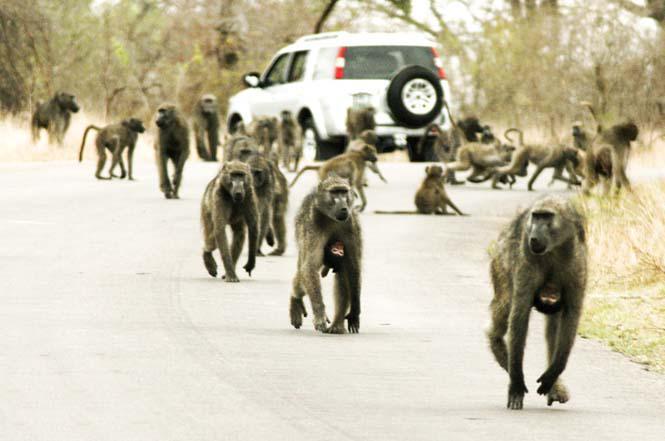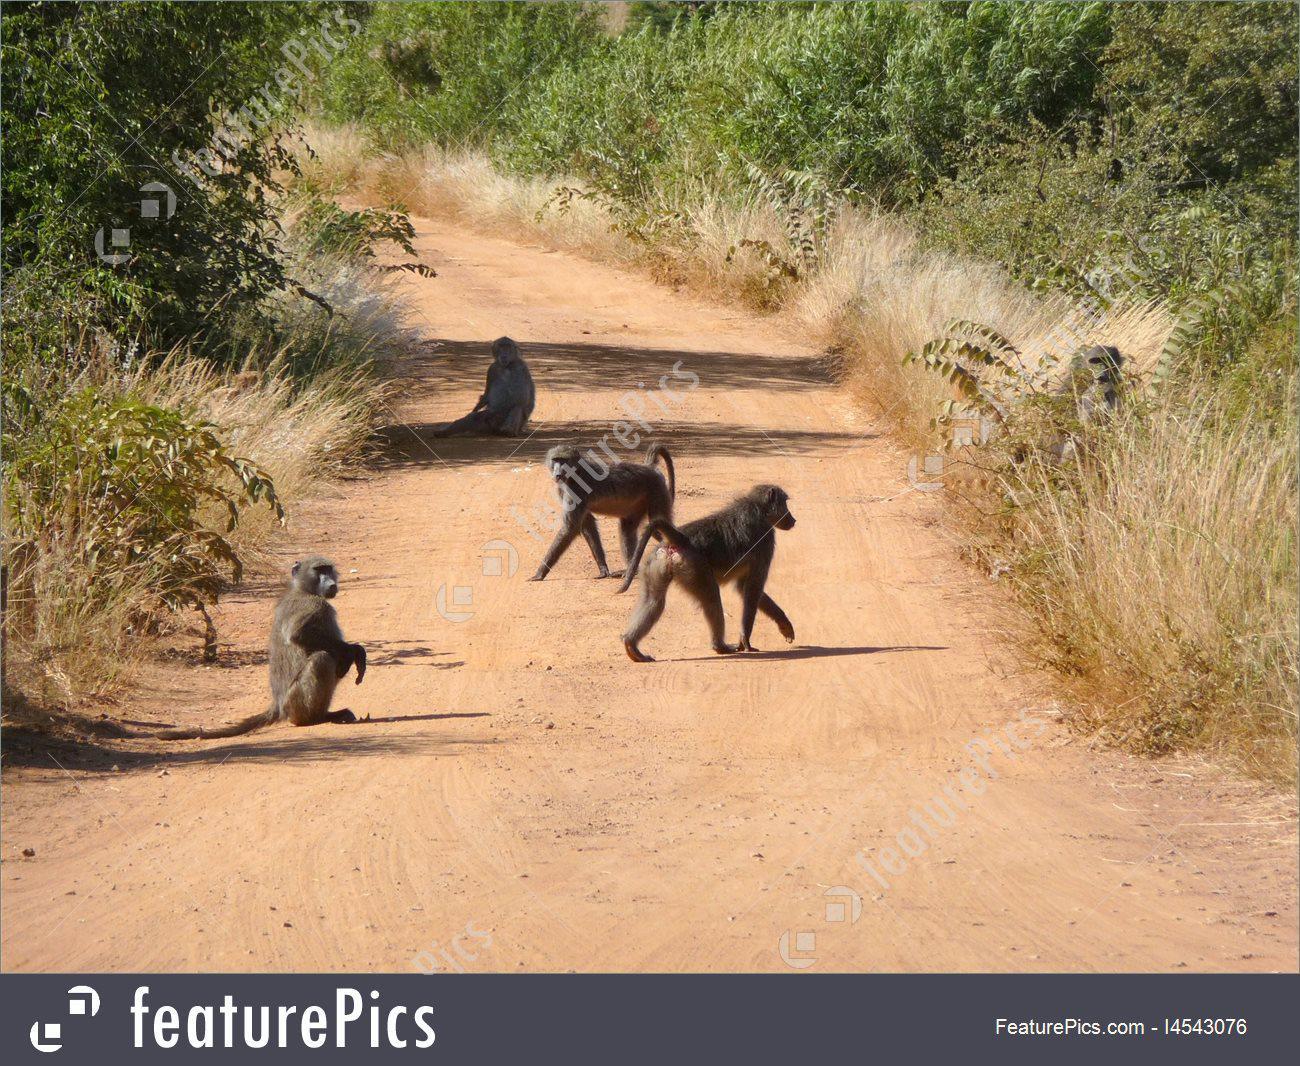The first image is the image on the left, the second image is the image on the right. Analyze the images presented: Is the assertion "One baboon sits with bent knees and its body turned leftward, in an image." valid? Answer yes or no. No. 